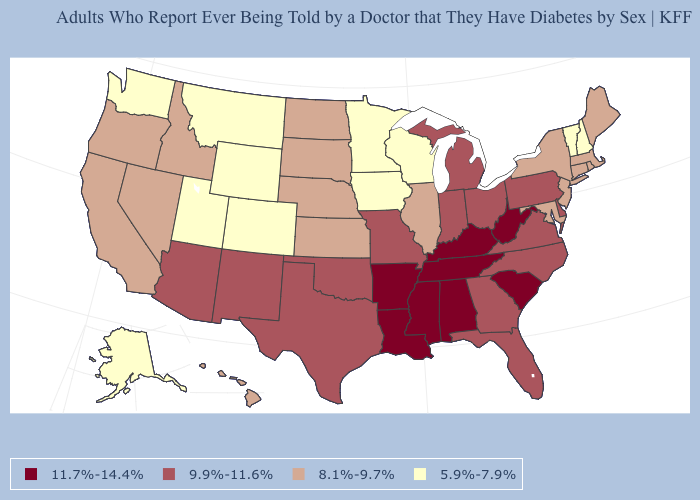Does Wisconsin have the lowest value in the USA?
Answer briefly. Yes. What is the value of New Hampshire?
Give a very brief answer. 5.9%-7.9%. Does the map have missing data?
Concise answer only. No. What is the lowest value in the USA?
Keep it brief. 5.9%-7.9%. Among the states that border New Hampshire , does Maine have the lowest value?
Keep it brief. No. Among the states that border Arizona , does Nevada have the lowest value?
Keep it brief. No. What is the value of Nebraska?
Give a very brief answer. 8.1%-9.7%. Does Georgia have the lowest value in the USA?
Answer briefly. No. How many symbols are there in the legend?
Keep it brief. 4. What is the value of Michigan?
Write a very short answer. 9.9%-11.6%. Among the states that border Nebraska , does Colorado have the lowest value?
Write a very short answer. Yes. Name the states that have a value in the range 5.9%-7.9%?
Quick response, please. Alaska, Colorado, Iowa, Minnesota, Montana, New Hampshire, Utah, Vermont, Washington, Wisconsin, Wyoming. Among the states that border Minnesota , does Iowa have the lowest value?
Quick response, please. Yes. Which states have the lowest value in the South?
Short answer required. Maryland. 